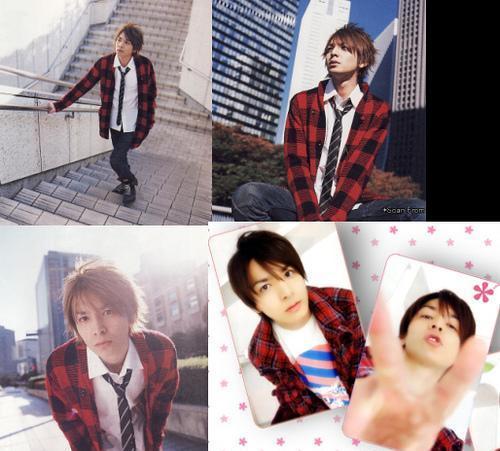How many pictures are shown?
Give a very brief answer. 4. 